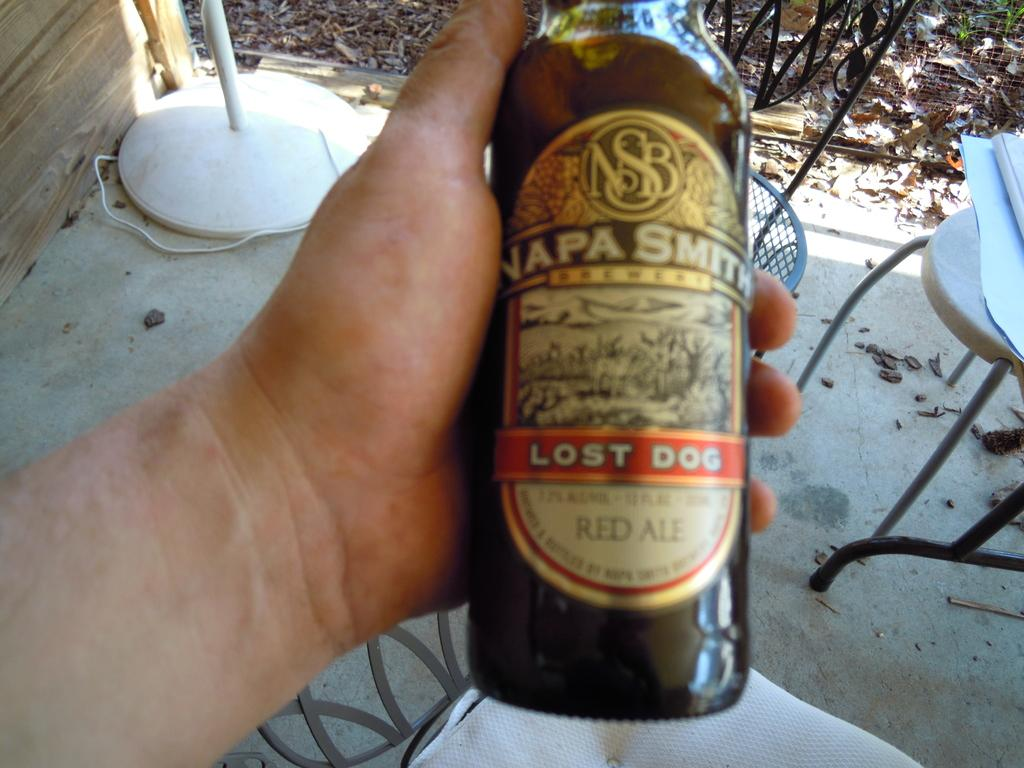<image>
Write a terse but informative summary of the picture. the words lost dog are on a beer bottle 